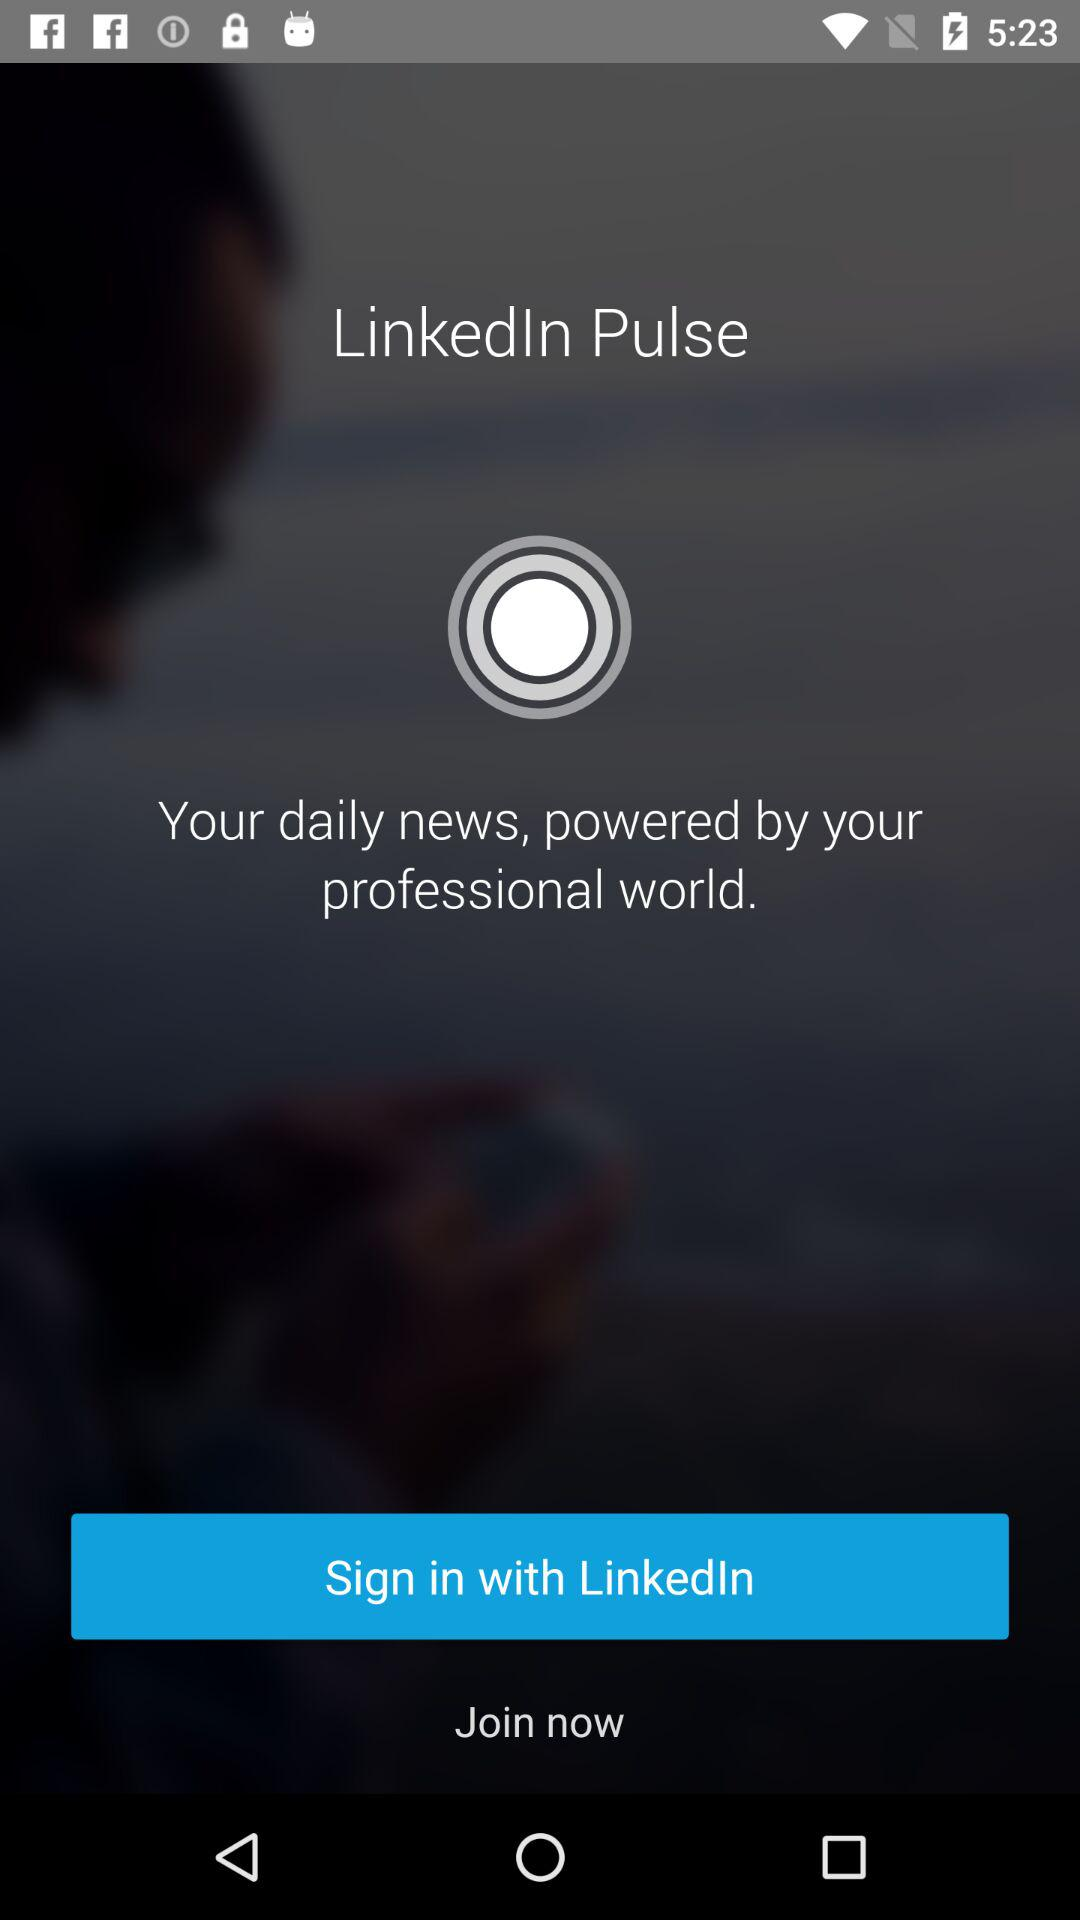What is the application name? The application name is "LinkedIn Pulse". 